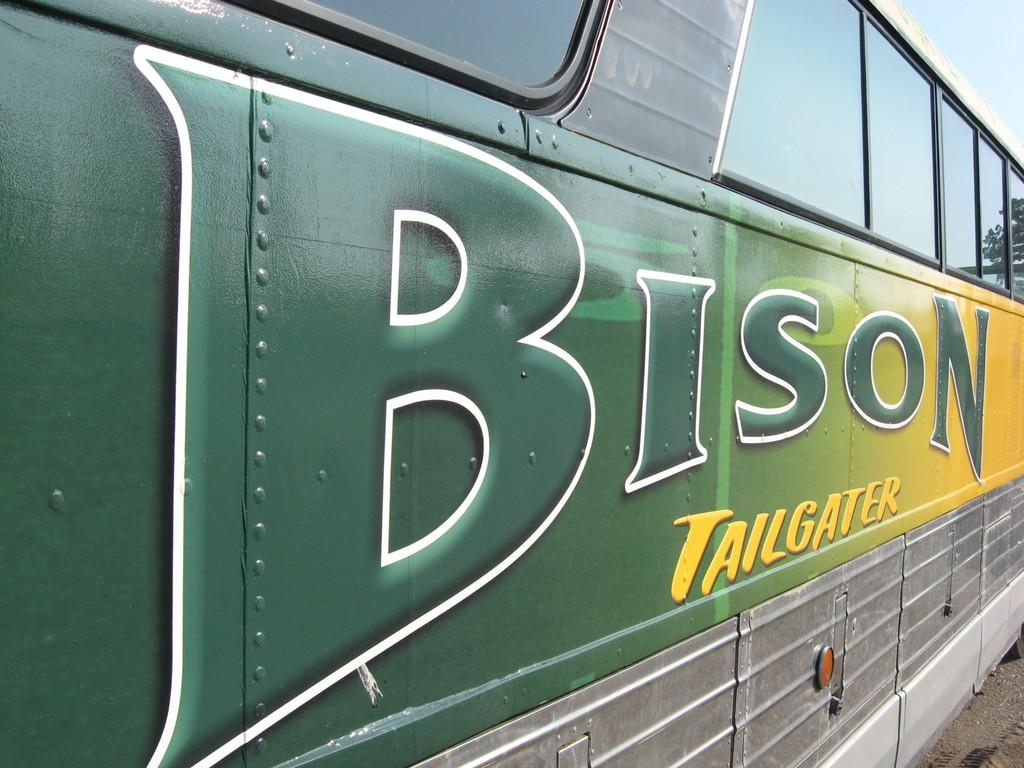Provide a one-sentence caption for the provided image. THE SIDE OF GREEN AND YELLOW A BISON TAILGATER BUS. 